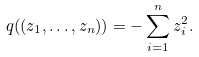<formula> <loc_0><loc_0><loc_500><loc_500>q ( ( z _ { 1 } , \dots , z _ { n } ) ) = - \sum _ { i = 1 } ^ { n } z _ { i } ^ { 2 } .</formula> 